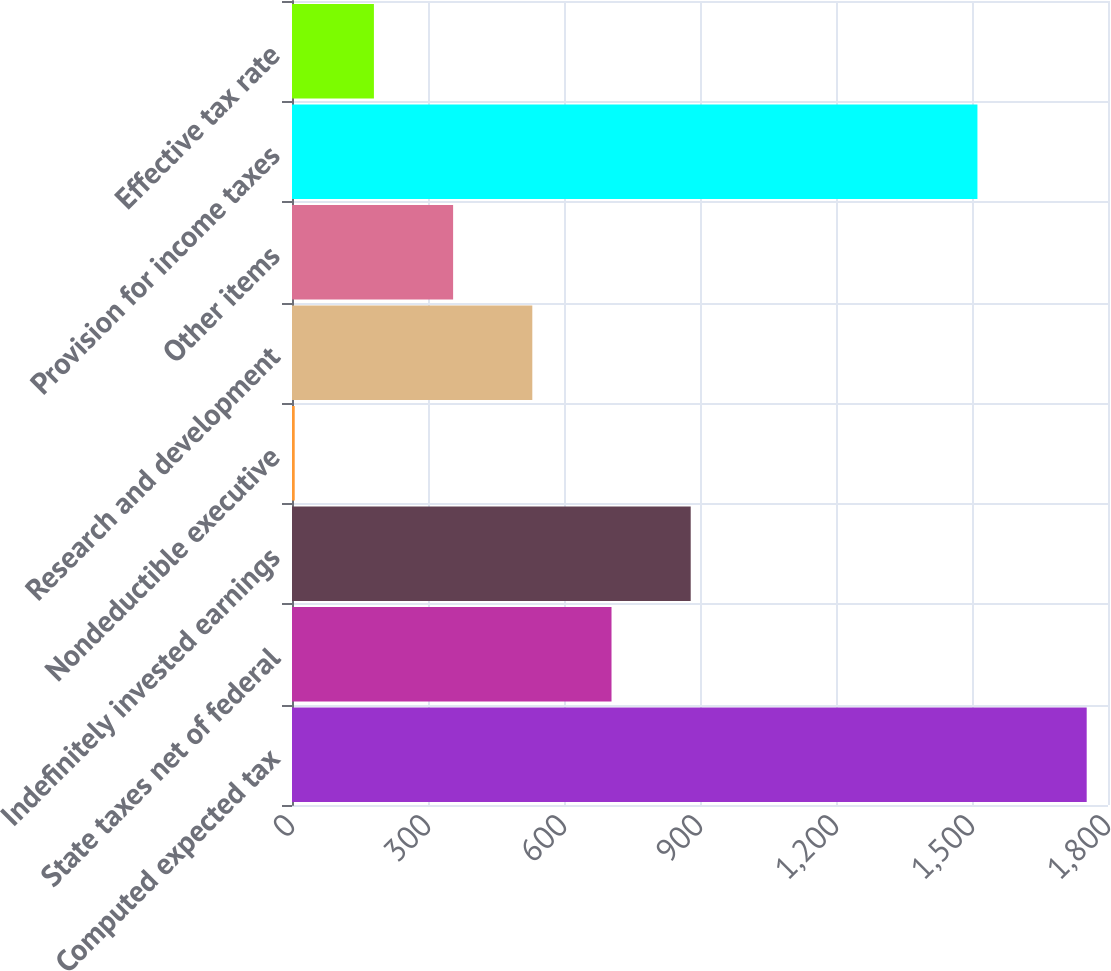Convert chart. <chart><loc_0><loc_0><loc_500><loc_500><bar_chart><fcel>Computed expected tax<fcel>State taxes net of federal<fcel>Indefinitely invested earnings<fcel>Nondeductible executive<fcel>Research and development<fcel>Other items<fcel>Provision for income taxes<fcel>Effective tax rate<nl><fcel>1753<fcel>704.8<fcel>879.5<fcel>6<fcel>530.1<fcel>355.4<fcel>1512<fcel>180.7<nl></chart> 